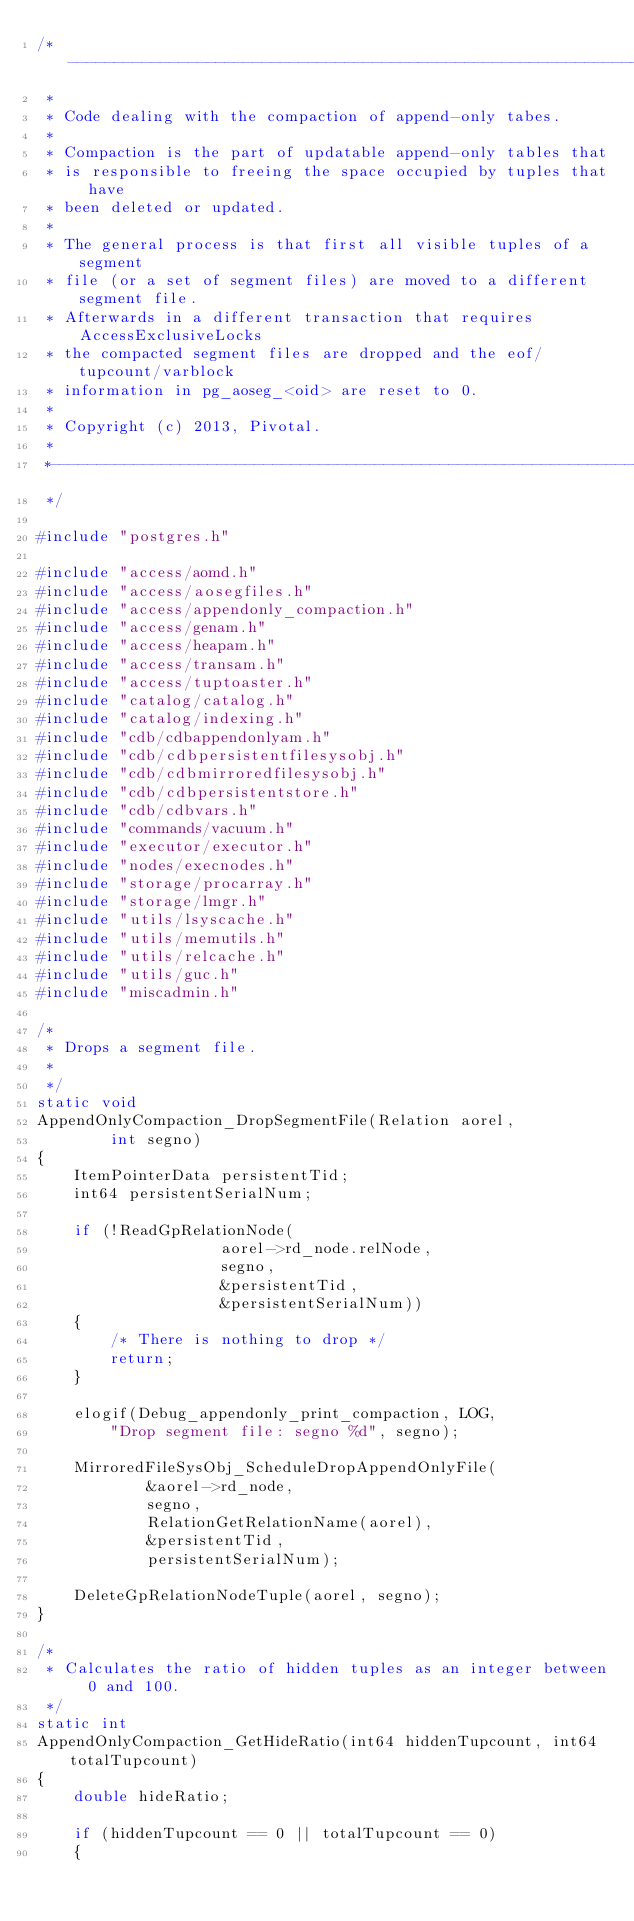<code> <loc_0><loc_0><loc_500><loc_500><_C_>/*------------------------------------------------------------------------------
 *
 * Code dealing with the compaction of append-only tabes.
 *
 * Compaction is the part of updatable append-only tables that
 * is responsible to freeing the space occupied by tuples that have
 * been deleted or updated.
 *
 * The general process is that first all visible tuples of a segment
 * file (or a set of segment files) are moved to a different segment file.
 * Afterwards in a different transaction that requires AccessExclusiveLocks
 * the compacted segment files are dropped and the eof/tupcount/varblock
 * information in pg_aoseg_<oid> are reset to 0.
 *
 * Copyright (c) 2013, Pivotal.
 *
 *------------------------------------------------------------------------------
 */

#include "postgres.h"

#include "access/aomd.h"
#include "access/aosegfiles.h"
#include "access/appendonly_compaction.h"
#include "access/genam.h"
#include "access/heapam.h"
#include "access/transam.h"
#include "access/tuptoaster.h"
#include "catalog/catalog.h"
#include "catalog/indexing.h"
#include "cdb/cdbappendonlyam.h"
#include "cdb/cdbpersistentfilesysobj.h"
#include "cdb/cdbmirroredfilesysobj.h"
#include "cdb/cdbpersistentstore.h"
#include "cdb/cdbvars.h"
#include "commands/vacuum.h"
#include "executor/executor.h"
#include "nodes/execnodes.h"
#include "storage/procarray.h"
#include "storage/lmgr.h"
#include "utils/lsyscache.h"
#include "utils/memutils.h"
#include "utils/relcache.h"
#include "utils/guc.h"
#include "miscadmin.h"

/*
 * Drops a segment file.
 *
 */ 
static void
AppendOnlyCompaction_DropSegmentFile(Relation aorel,
		int segno)
{
	ItemPointerData persistentTid; 
	int64 persistentSerialNum;

	if (!ReadGpRelationNode(
					aorel->rd_node.relNode,
					segno,
					&persistentTid,
					&persistentSerialNum))
	{
		/* There is nothing to drop */
		return;
	}

	elogif(Debug_appendonly_print_compaction, LOG, 
		"Drop segment file: segno %d", segno);

	MirroredFileSysObj_ScheduleDropAppendOnlyFile(
			&aorel->rd_node,
			segno,
			RelationGetRelationName(aorel),
			&persistentTid,
			persistentSerialNum);

	DeleteGpRelationNodeTuple(aorel, segno);
}

/*
 * Calculates the ratio of hidden tuples as an integer between 0 and 100.
 */
static int
AppendOnlyCompaction_GetHideRatio(int64 hiddenTupcount, int64 totalTupcount)
{
	double hideRatio;

	if (hiddenTupcount == 0 || totalTupcount == 0)
	{</code> 